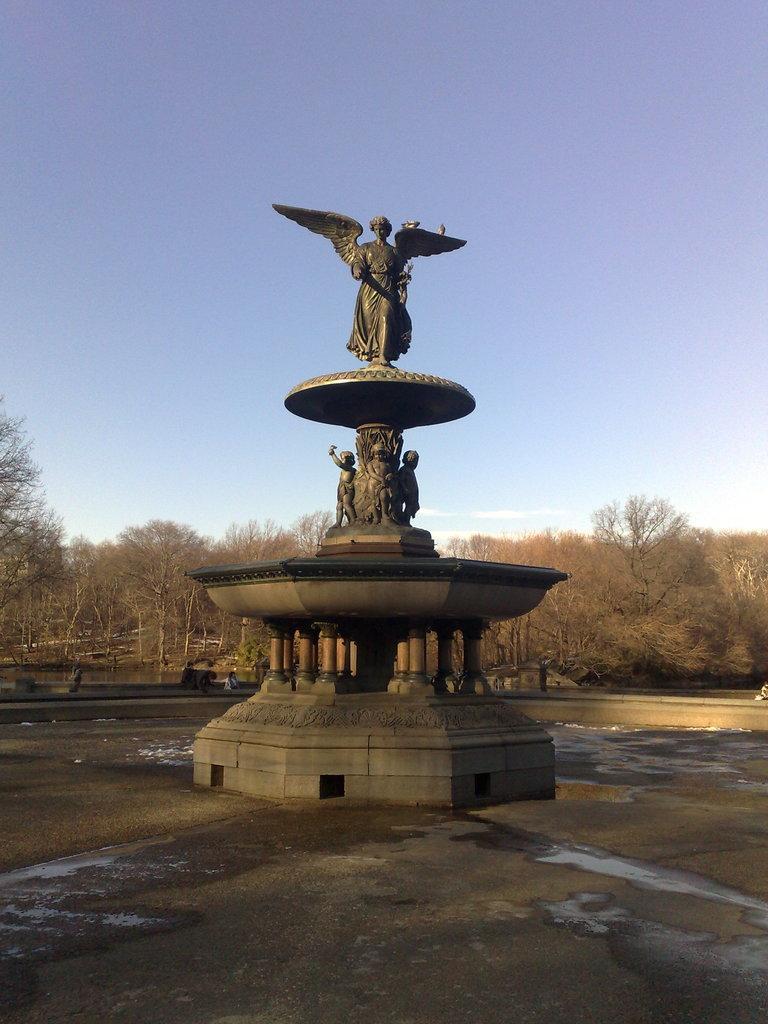Please provide a concise description of this image. In this image I can see a fountain. In the background, I can see the trees and clouds in the sky. 